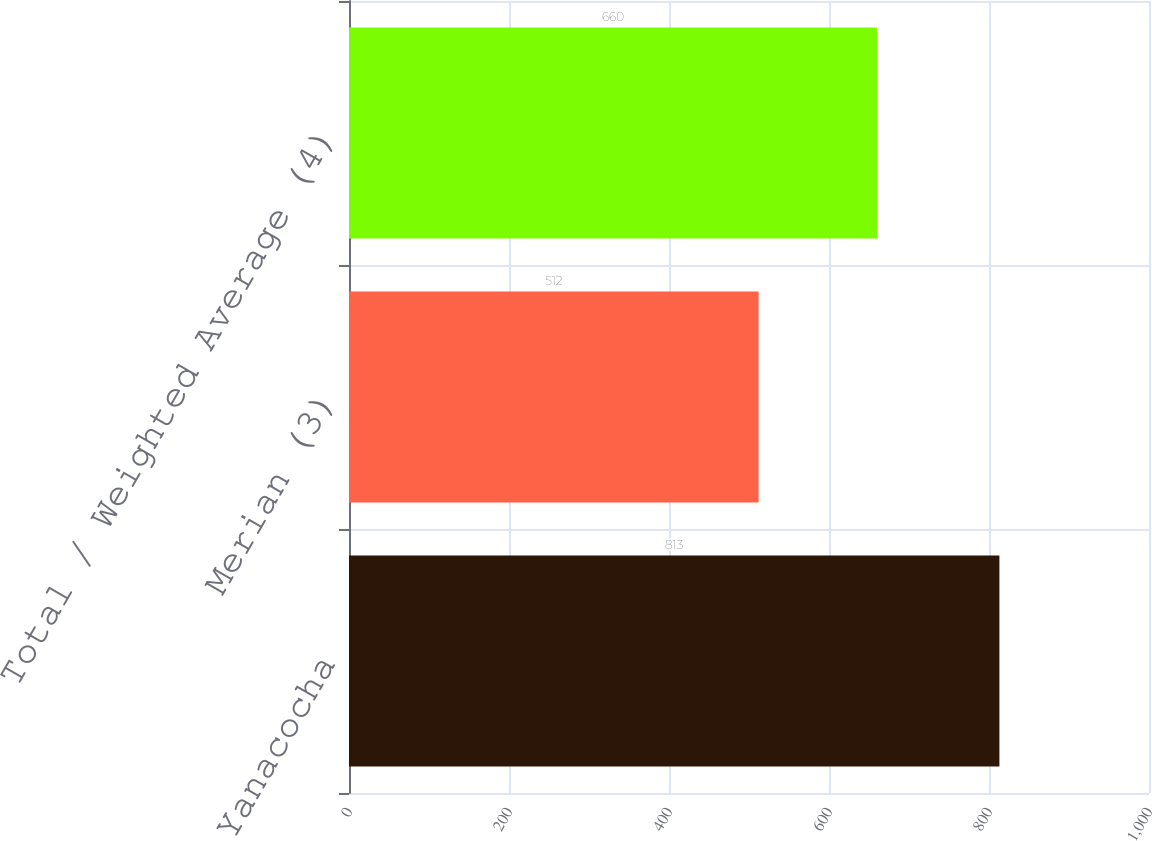<chart> <loc_0><loc_0><loc_500><loc_500><bar_chart><fcel>Yanacocha<fcel>Merian (3)<fcel>Total / Weighted Average (4)<nl><fcel>813<fcel>512<fcel>660<nl></chart> 